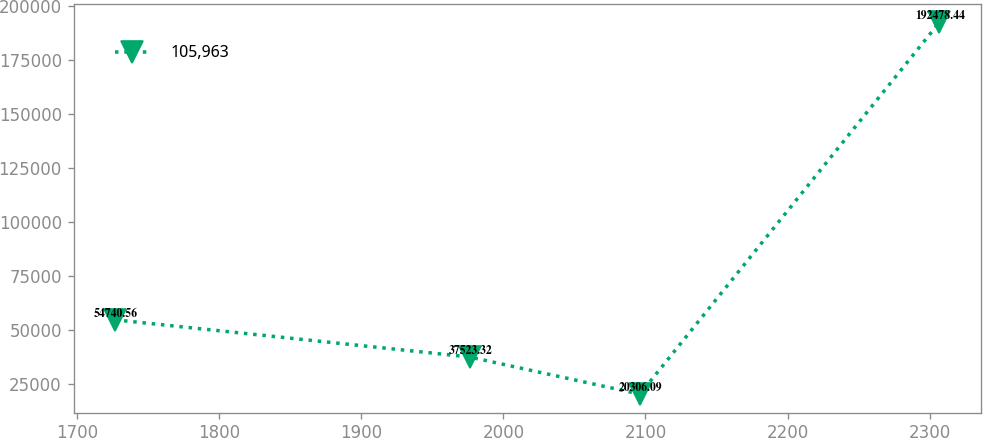Convert chart. <chart><loc_0><loc_0><loc_500><loc_500><line_chart><ecel><fcel>105,963<nl><fcel>1726.62<fcel>54740.6<nl><fcel>1976.22<fcel>37523.3<nl><fcel>2096.06<fcel>20306.1<nl><fcel>2306.84<fcel>192478<nl></chart> 